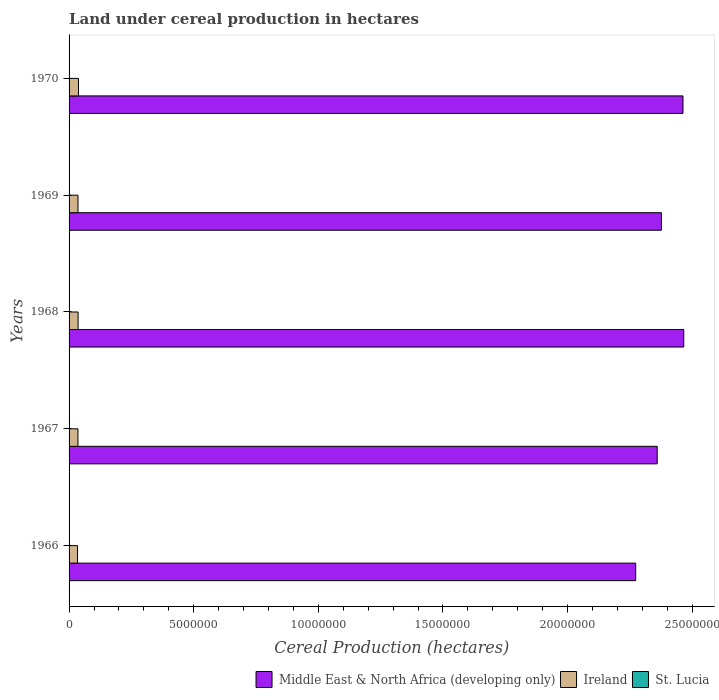Are the number of bars per tick equal to the number of legend labels?
Your response must be concise. Yes. Are the number of bars on each tick of the Y-axis equal?
Offer a very short reply. Yes. How many bars are there on the 4th tick from the top?
Offer a terse response. 3. How many bars are there on the 1st tick from the bottom?
Your answer should be compact. 3. What is the label of the 2nd group of bars from the top?
Offer a very short reply. 1969. In how many cases, is the number of bars for a given year not equal to the number of legend labels?
Your answer should be compact. 0. What is the land under cereal production in Ireland in 1970?
Ensure brevity in your answer.  3.77e+05. Across all years, what is the maximum land under cereal production in St. Lucia?
Keep it short and to the point. 28. Across all years, what is the minimum land under cereal production in Middle East & North Africa (developing only)?
Give a very brief answer. 2.27e+07. In which year was the land under cereal production in Middle East & North Africa (developing only) maximum?
Provide a short and direct response. 1968. In which year was the land under cereal production in Ireland minimum?
Offer a very short reply. 1966. What is the total land under cereal production in St. Lucia in the graph?
Your answer should be very brief. 119. What is the difference between the land under cereal production in St. Lucia in 1966 and that in 1967?
Your answer should be very brief. 0. What is the difference between the land under cereal production in St. Lucia in 1966 and the land under cereal production in Middle East & North Africa (developing only) in 1969?
Offer a terse response. -2.38e+07. What is the average land under cereal production in Ireland per year?
Your response must be concise. 3.59e+05. In the year 1966, what is the difference between the land under cereal production in Middle East & North Africa (developing only) and land under cereal production in St. Lucia?
Your answer should be very brief. 2.27e+07. What is the ratio of the land under cereal production in St. Lucia in 1967 to that in 1969?
Keep it short and to the point. 0.71. Is the difference between the land under cereal production in Middle East & North Africa (developing only) in 1966 and 1968 greater than the difference between the land under cereal production in St. Lucia in 1966 and 1968?
Your answer should be compact. No. What is the difference between the highest and the second highest land under cereal production in Middle East & North Africa (developing only)?
Your answer should be compact. 3.12e+04. What is the difference between the highest and the lowest land under cereal production in Ireland?
Offer a very short reply. 3.86e+04. In how many years, is the land under cereal production in St. Lucia greater than the average land under cereal production in St. Lucia taken over all years?
Your answer should be very brief. 3. What does the 3rd bar from the top in 1966 represents?
Your response must be concise. Middle East & North Africa (developing only). What does the 1st bar from the bottom in 1966 represents?
Offer a terse response. Middle East & North Africa (developing only). Is it the case that in every year, the sum of the land under cereal production in Middle East & North Africa (developing only) and land under cereal production in Ireland is greater than the land under cereal production in St. Lucia?
Your answer should be compact. Yes. How many years are there in the graph?
Provide a succinct answer. 5. Does the graph contain any zero values?
Keep it short and to the point. No. Does the graph contain grids?
Provide a short and direct response. No. Where does the legend appear in the graph?
Keep it short and to the point. Bottom right. How are the legend labels stacked?
Provide a succinct answer. Horizontal. What is the title of the graph?
Keep it short and to the point. Land under cereal production in hectares. Does "East Asia (all income levels)" appear as one of the legend labels in the graph?
Give a very brief answer. No. What is the label or title of the X-axis?
Provide a short and direct response. Cereal Production (hectares). What is the label or title of the Y-axis?
Your response must be concise. Years. What is the Cereal Production (hectares) of Middle East & North Africa (developing only) in 1966?
Keep it short and to the point. 2.27e+07. What is the Cereal Production (hectares) in Ireland in 1966?
Your answer should be compact. 3.39e+05. What is the Cereal Production (hectares) of Middle East & North Africa (developing only) in 1967?
Your answer should be compact. 2.36e+07. What is the Cereal Production (hectares) in Ireland in 1967?
Provide a short and direct response. 3.56e+05. What is the Cereal Production (hectares) of Middle East & North Africa (developing only) in 1968?
Make the answer very short. 2.47e+07. What is the Cereal Production (hectares) in Ireland in 1968?
Provide a short and direct response. 3.62e+05. What is the Cereal Production (hectares) in Middle East & North Africa (developing only) in 1969?
Your response must be concise. 2.38e+07. What is the Cereal Production (hectares) of Ireland in 1969?
Offer a very short reply. 3.58e+05. What is the Cereal Production (hectares) in St. Lucia in 1969?
Your response must be concise. 28. What is the Cereal Production (hectares) in Middle East & North Africa (developing only) in 1970?
Keep it short and to the point. 2.46e+07. What is the Cereal Production (hectares) of Ireland in 1970?
Provide a short and direct response. 3.77e+05. What is the Cereal Production (hectares) of St. Lucia in 1970?
Provide a short and direct response. 25. Across all years, what is the maximum Cereal Production (hectares) in Middle East & North Africa (developing only)?
Provide a short and direct response. 2.47e+07. Across all years, what is the maximum Cereal Production (hectares) of Ireland?
Offer a very short reply. 3.77e+05. Across all years, what is the minimum Cereal Production (hectares) in Middle East & North Africa (developing only)?
Your answer should be compact. 2.27e+07. Across all years, what is the minimum Cereal Production (hectares) of Ireland?
Offer a very short reply. 3.39e+05. Across all years, what is the minimum Cereal Production (hectares) in St. Lucia?
Offer a very short reply. 20. What is the total Cereal Production (hectares) in Middle East & North Africa (developing only) in the graph?
Offer a very short reply. 1.19e+08. What is the total Cereal Production (hectares) in Ireland in the graph?
Your answer should be very brief. 1.79e+06. What is the total Cereal Production (hectares) of St. Lucia in the graph?
Offer a terse response. 119. What is the difference between the Cereal Production (hectares) in Middle East & North Africa (developing only) in 1966 and that in 1967?
Give a very brief answer. -8.64e+05. What is the difference between the Cereal Production (hectares) in Ireland in 1966 and that in 1967?
Provide a short and direct response. -1.75e+04. What is the difference between the Cereal Production (hectares) of St. Lucia in 1966 and that in 1967?
Your answer should be compact. 0. What is the difference between the Cereal Production (hectares) in Middle East & North Africa (developing only) in 1966 and that in 1968?
Ensure brevity in your answer.  -1.93e+06. What is the difference between the Cereal Production (hectares) of Ireland in 1966 and that in 1968?
Your response must be concise. -2.38e+04. What is the difference between the Cereal Production (hectares) in Middle East & North Africa (developing only) in 1966 and that in 1969?
Give a very brief answer. -1.03e+06. What is the difference between the Cereal Production (hectares) in Ireland in 1966 and that in 1969?
Your answer should be very brief. -1.92e+04. What is the difference between the Cereal Production (hectares) in St. Lucia in 1966 and that in 1969?
Your answer should be very brief. -8. What is the difference between the Cereal Production (hectares) of Middle East & North Africa (developing only) in 1966 and that in 1970?
Provide a succinct answer. -1.90e+06. What is the difference between the Cereal Production (hectares) in Ireland in 1966 and that in 1970?
Provide a short and direct response. -3.86e+04. What is the difference between the Cereal Production (hectares) in Middle East & North Africa (developing only) in 1967 and that in 1968?
Your response must be concise. -1.06e+06. What is the difference between the Cereal Production (hectares) in Ireland in 1967 and that in 1968?
Your answer should be compact. -6309. What is the difference between the Cereal Production (hectares) of Middle East & North Africa (developing only) in 1967 and that in 1969?
Provide a succinct answer. -1.70e+05. What is the difference between the Cereal Production (hectares) in Ireland in 1967 and that in 1969?
Make the answer very short. -1773. What is the difference between the Cereal Production (hectares) of St. Lucia in 1967 and that in 1969?
Your answer should be very brief. -8. What is the difference between the Cereal Production (hectares) in Middle East & North Africa (developing only) in 1967 and that in 1970?
Keep it short and to the point. -1.03e+06. What is the difference between the Cereal Production (hectares) of Ireland in 1967 and that in 1970?
Your answer should be very brief. -2.11e+04. What is the difference between the Cereal Production (hectares) in St. Lucia in 1967 and that in 1970?
Provide a short and direct response. -5. What is the difference between the Cereal Production (hectares) of Middle East & North Africa (developing only) in 1968 and that in 1969?
Offer a terse response. 8.95e+05. What is the difference between the Cereal Production (hectares) in Ireland in 1968 and that in 1969?
Your answer should be compact. 4536. What is the difference between the Cereal Production (hectares) of Middle East & North Africa (developing only) in 1968 and that in 1970?
Your response must be concise. 3.12e+04. What is the difference between the Cereal Production (hectares) of Ireland in 1968 and that in 1970?
Your answer should be very brief. -1.48e+04. What is the difference between the Cereal Production (hectares) in St. Lucia in 1968 and that in 1970?
Ensure brevity in your answer.  1. What is the difference between the Cereal Production (hectares) of Middle East & North Africa (developing only) in 1969 and that in 1970?
Keep it short and to the point. -8.64e+05. What is the difference between the Cereal Production (hectares) in Ireland in 1969 and that in 1970?
Keep it short and to the point. -1.93e+04. What is the difference between the Cereal Production (hectares) of Middle East & North Africa (developing only) in 1966 and the Cereal Production (hectares) of Ireland in 1967?
Make the answer very short. 2.24e+07. What is the difference between the Cereal Production (hectares) in Middle East & North Africa (developing only) in 1966 and the Cereal Production (hectares) in St. Lucia in 1967?
Keep it short and to the point. 2.27e+07. What is the difference between the Cereal Production (hectares) of Ireland in 1966 and the Cereal Production (hectares) of St. Lucia in 1967?
Provide a short and direct response. 3.39e+05. What is the difference between the Cereal Production (hectares) in Middle East & North Africa (developing only) in 1966 and the Cereal Production (hectares) in Ireland in 1968?
Offer a terse response. 2.24e+07. What is the difference between the Cereal Production (hectares) of Middle East & North Africa (developing only) in 1966 and the Cereal Production (hectares) of St. Lucia in 1968?
Provide a short and direct response. 2.27e+07. What is the difference between the Cereal Production (hectares) in Ireland in 1966 and the Cereal Production (hectares) in St. Lucia in 1968?
Offer a terse response. 3.39e+05. What is the difference between the Cereal Production (hectares) of Middle East & North Africa (developing only) in 1966 and the Cereal Production (hectares) of Ireland in 1969?
Keep it short and to the point. 2.24e+07. What is the difference between the Cereal Production (hectares) of Middle East & North Africa (developing only) in 1966 and the Cereal Production (hectares) of St. Lucia in 1969?
Your answer should be compact. 2.27e+07. What is the difference between the Cereal Production (hectares) in Ireland in 1966 and the Cereal Production (hectares) in St. Lucia in 1969?
Offer a terse response. 3.39e+05. What is the difference between the Cereal Production (hectares) in Middle East & North Africa (developing only) in 1966 and the Cereal Production (hectares) in Ireland in 1970?
Your response must be concise. 2.24e+07. What is the difference between the Cereal Production (hectares) of Middle East & North Africa (developing only) in 1966 and the Cereal Production (hectares) of St. Lucia in 1970?
Your answer should be very brief. 2.27e+07. What is the difference between the Cereal Production (hectares) of Ireland in 1966 and the Cereal Production (hectares) of St. Lucia in 1970?
Provide a short and direct response. 3.39e+05. What is the difference between the Cereal Production (hectares) of Middle East & North Africa (developing only) in 1967 and the Cereal Production (hectares) of Ireland in 1968?
Offer a very short reply. 2.32e+07. What is the difference between the Cereal Production (hectares) of Middle East & North Africa (developing only) in 1967 and the Cereal Production (hectares) of St. Lucia in 1968?
Give a very brief answer. 2.36e+07. What is the difference between the Cereal Production (hectares) of Ireland in 1967 and the Cereal Production (hectares) of St. Lucia in 1968?
Ensure brevity in your answer.  3.56e+05. What is the difference between the Cereal Production (hectares) in Middle East & North Africa (developing only) in 1967 and the Cereal Production (hectares) in Ireland in 1969?
Provide a short and direct response. 2.32e+07. What is the difference between the Cereal Production (hectares) of Middle East & North Africa (developing only) in 1967 and the Cereal Production (hectares) of St. Lucia in 1969?
Provide a succinct answer. 2.36e+07. What is the difference between the Cereal Production (hectares) of Ireland in 1967 and the Cereal Production (hectares) of St. Lucia in 1969?
Provide a short and direct response. 3.56e+05. What is the difference between the Cereal Production (hectares) of Middle East & North Africa (developing only) in 1967 and the Cereal Production (hectares) of Ireland in 1970?
Offer a terse response. 2.32e+07. What is the difference between the Cereal Production (hectares) in Middle East & North Africa (developing only) in 1967 and the Cereal Production (hectares) in St. Lucia in 1970?
Provide a short and direct response. 2.36e+07. What is the difference between the Cereal Production (hectares) in Ireland in 1967 and the Cereal Production (hectares) in St. Lucia in 1970?
Ensure brevity in your answer.  3.56e+05. What is the difference between the Cereal Production (hectares) of Middle East & North Africa (developing only) in 1968 and the Cereal Production (hectares) of Ireland in 1969?
Make the answer very short. 2.43e+07. What is the difference between the Cereal Production (hectares) in Middle East & North Africa (developing only) in 1968 and the Cereal Production (hectares) in St. Lucia in 1969?
Your answer should be very brief. 2.47e+07. What is the difference between the Cereal Production (hectares) of Ireland in 1968 and the Cereal Production (hectares) of St. Lucia in 1969?
Keep it short and to the point. 3.62e+05. What is the difference between the Cereal Production (hectares) of Middle East & North Africa (developing only) in 1968 and the Cereal Production (hectares) of Ireland in 1970?
Make the answer very short. 2.43e+07. What is the difference between the Cereal Production (hectares) of Middle East & North Africa (developing only) in 1968 and the Cereal Production (hectares) of St. Lucia in 1970?
Your answer should be compact. 2.47e+07. What is the difference between the Cereal Production (hectares) of Ireland in 1968 and the Cereal Production (hectares) of St. Lucia in 1970?
Make the answer very short. 3.62e+05. What is the difference between the Cereal Production (hectares) of Middle East & North Africa (developing only) in 1969 and the Cereal Production (hectares) of Ireland in 1970?
Your response must be concise. 2.34e+07. What is the difference between the Cereal Production (hectares) of Middle East & North Africa (developing only) in 1969 and the Cereal Production (hectares) of St. Lucia in 1970?
Offer a very short reply. 2.38e+07. What is the difference between the Cereal Production (hectares) of Ireland in 1969 and the Cereal Production (hectares) of St. Lucia in 1970?
Ensure brevity in your answer.  3.58e+05. What is the average Cereal Production (hectares) of Middle East & North Africa (developing only) per year?
Your answer should be compact. 2.39e+07. What is the average Cereal Production (hectares) in Ireland per year?
Make the answer very short. 3.59e+05. What is the average Cereal Production (hectares) of St. Lucia per year?
Keep it short and to the point. 23.8. In the year 1966, what is the difference between the Cereal Production (hectares) in Middle East & North Africa (developing only) and Cereal Production (hectares) in Ireland?
Ensure brevity in your answer.  2.24e+07. In the year 1966, what is the difference between the Cereal Production (hectares) in Middle East & North Africa (developing only) and Cereal Production (hectares) in St. Lucia?
Offer a very short reply. 2.27e+07. In the year 1966, what is the difference between the Cereal Production (hectares) of Ireland and Cereal Production (hectares) of St. Lucia?
Ensure brevity in your answer.  3.39e+05. In the year 1967, what is the difference between the Cereal Production (hectares) in Middle East & North Africa (developing only) and Cereal Production (hectares) in Ireland?
Give a very brief answer. 2.32e+07. In the year 1967, what is the difference between the Cereal Production (hectares) of Middle East & North Africa (developing only) and Cereal Production (hectares) of St. Lucia?
Your answer should be very brief. 2.36e+07. In the year 1967, what is the difference between the Cereal Production (hectares) in Ireland and Cereal Production (hectares) in St. Lucia?
Make the answer very short. 3.56e+05. In the year 1968, what is the difference between the Cereal Production (hectares) in Middle East & North Africa (developing only) and Cereal Production (hectares) in Ireland?
Make the answer very short. 2.43e+07. In the year 1968, what is the difference between the Cereal Production (hectares) in Middle East & North Africa (developing only) and Cereal Production (hectares) in St. Lucia?
Keep it short and to the point. 2.47e+07. In the year 1968, what is the difference between the Cereal Production (hectares) in Ireland and Cereal Production (hectares) in St. Lucia?
Offer a terse response. 3.62e+05. In the year 1969, what is the difference between the Cereal Production (hectares) in Middle East & North Africa (developing only) and Cereal Production (hectares) in Ireland?
Offer a very short reply. 2.34e+07. In the year 1969, what is the difference between the Cereal Production (hectares) in Middle East & North Africa (developing only) and Cereal Production (hectares) in St. Lucia?
Your answer should be compact. 2.38e+07. In the year 1969, what is the difference between the Cereal Production (hectares) of Ireland and Cereal Production (hectares) of St. Lucia?
Your answer should be very brief. 3.58e+05. In the year 1970, what is the difference between the Cereal Production (hectares) of Middle East & North Africa (developing only) and Cereal Production (hectares) of Ireland?
Provide a short and direct response. 2.43e+07. In the year 1970, what is the difference between the Cereal Production (hectares) of Middle East & North Africa (developing only) and Cereal Production (hectares) of St. Lucia?
Keep it short and to the point. 2.46e+07. In the year 1970, what is the difference between the Cereal Production (hectares) of Ireland and Cereal Production (hectares) of St. Lucia?
Provide a succinct answer. 3.77e+05. What is the ratio of the Cereal Production (hectares) in Middle East & North Africa (developing only) in 1966 to that in 1967?
Provide a succinct answer. 0.96. What is the ratio of the Cereal Production (hectares) of Ireland in 1966 to that in 1967?
Your response must be concise. 0.95. What is the ratio of the Cereal Production (hectares) of St. Lucia in 1966 to that in 1967?
Offer a terse response. 1. What is the ratio of the Cereal Production (hectares) of Middle East & North Africa (developing only) in 1966 to that in 1968?
Ensure brevity in your answer.  0.92. What is the ratio of the Cereal Production (hectares) of Ireland in 1966 to that in 1968?
Make the answer very short. 0.93. What is the ratio of the Cereal Production (hectares) in St. Lucia in 1966 to that in 1968?
Offer a terse response. 0.77. What is the ratio of the Cereal Production (hectares) in Middle East & North Africa (developing only) in 1966 to that in 1969?
Give a very brief answer. 0.96. What is the ratio of the Cereal Production (hectares) in Ireland in 1966 to that in 1969?
Your answer should be very brief. 0.95. What is the ratio of the Cereal Production (hectares) of St. Lucia in 1966 to that in 1969?
Your answer should be compact. 0.71. What is the ratio of the Cereal Production (hectares) in Middle East & North Africa (developing only) in 1966 to that in 1970?
Keep it short and to the point. 0.92. What is the ratio of the Cereal Production (hectares) of Ireland in 1966 to that in 1970?
Your answer should be very brief. 0.9. What is the ratio of the Cereal Production (hectares) in Middle East & North Africa (developing only) in 1967 to that in 1968?
Provide a succinct answer. 0.96. What is the ratio of the Cereal Production (hectares) in Ireland in 1967 to that in 1968?
Your answer should be compact. 0.98. What is the ratio of the Cereal Production (hectares) of St. Lucia in 1967 to that in 1968?
Your response must be concise. 0.77. What is the ratio of the Cereal Production (hectares) of Middle East & North Africa (developing only) in 1967 to that in 1969?
Provide a short and direct response. 0.99. What is the ratio of the Cereal Production (hectares) in Ireland in 1967 to that in 1969?
Ensure brevity in your answer.  0.99. What is the ratio of the Cereal Production (hectares) in Middle East & North Africa (developing only) in 1967 to that in 1970?
Provide a short and direct response. 0.96. What is the ratio of the Cereal Production (hectares) in Ireland in 1967 to that in 1970?
Give a very brief answer. 0.94. What is the ratio of the Cereal Production (hectares) in Middle East & North Africa (developing only) in 1968 to that in 1969?
Give a very brief answer. 1.04. What is the ratio of the Cereal Production (hectares) of Ireland in 1968 to that in 1969?
Provide a succinct answer. 1.01. What is the ratio of the Cereal Production (hectares) of St. Lucia in 1968 to that in 1969?
Your answer should be compact. 0.93. What is the ratio of the Cereal Production (hectares) of Ireland in 1968 to that in 1970?
Offer a terse response. 0.96. What is the ratio of the Cereal Production (hectares) of St. Lucia in 1968 to that in 1970?
Your answer should be very brief. 1.04. What is the ratio of the Cereal Production (hectares) in Middle East & North Africa (developing only) in 1969 to that in 1970?
Make the answer very short. 0.96. What is the ratio of the Cereal Production (hectares) in Ireland in 1969 to that in 1970?
Your response must be concise. 0.95. What is the ratio of the Cereal Production (hectares) of St. Lucia in 1969 to that in 1970?
Provide a short and direct response. 1.12. What is the difference between the highest and the second highest Cereal Production (hectares) in Middle East & North Africa (developing only)?
Ensure brevity in your answer.  3.12e+04. What is the difference between the highest and the second highest Cereal Production (hectares) in Ireland?
Your response must be concise. 1.48e+04. What is the difference between the highest and the second highest Cereal Production (hectares) in St. Lucia?
Your answer should be compact. 2. What is the difference between the highest and the lowest Cereal Production (hectares) of Middle East & North Africa (developing only)?
Keep it short and to the point. 1.93e+06. What is the difference between the highest and the lowest Cereal Production (hectares) of Ireland?
Your answer should be very brief. 3.86e+04. What is the difference between the highest and the lowest Cereal Production (hectares) of St. Lucia?
Your response must be concise. 8. 